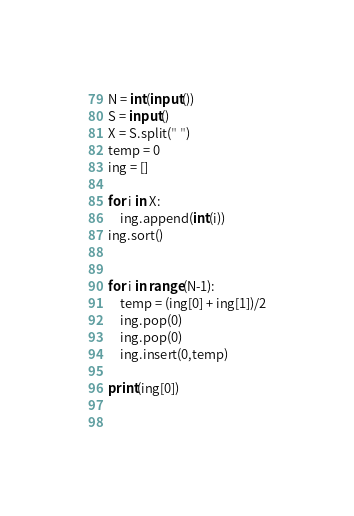Convert code to text. <code><loc_0><loc_0><loc_500><loc_500><_Python_>N = int(input())
S = input()
X = S.split(" ")
temp = 0
ing = []

for i in X:
    ing.append(int(i))
ing.sort()


for i in range(N-1):
    temp = (ing[0] + ing[1])/2
    ing.pop(0)
    ing.pop(0)
    ing.insert(0,temp)

print(ing[0])
    
    

</code> 